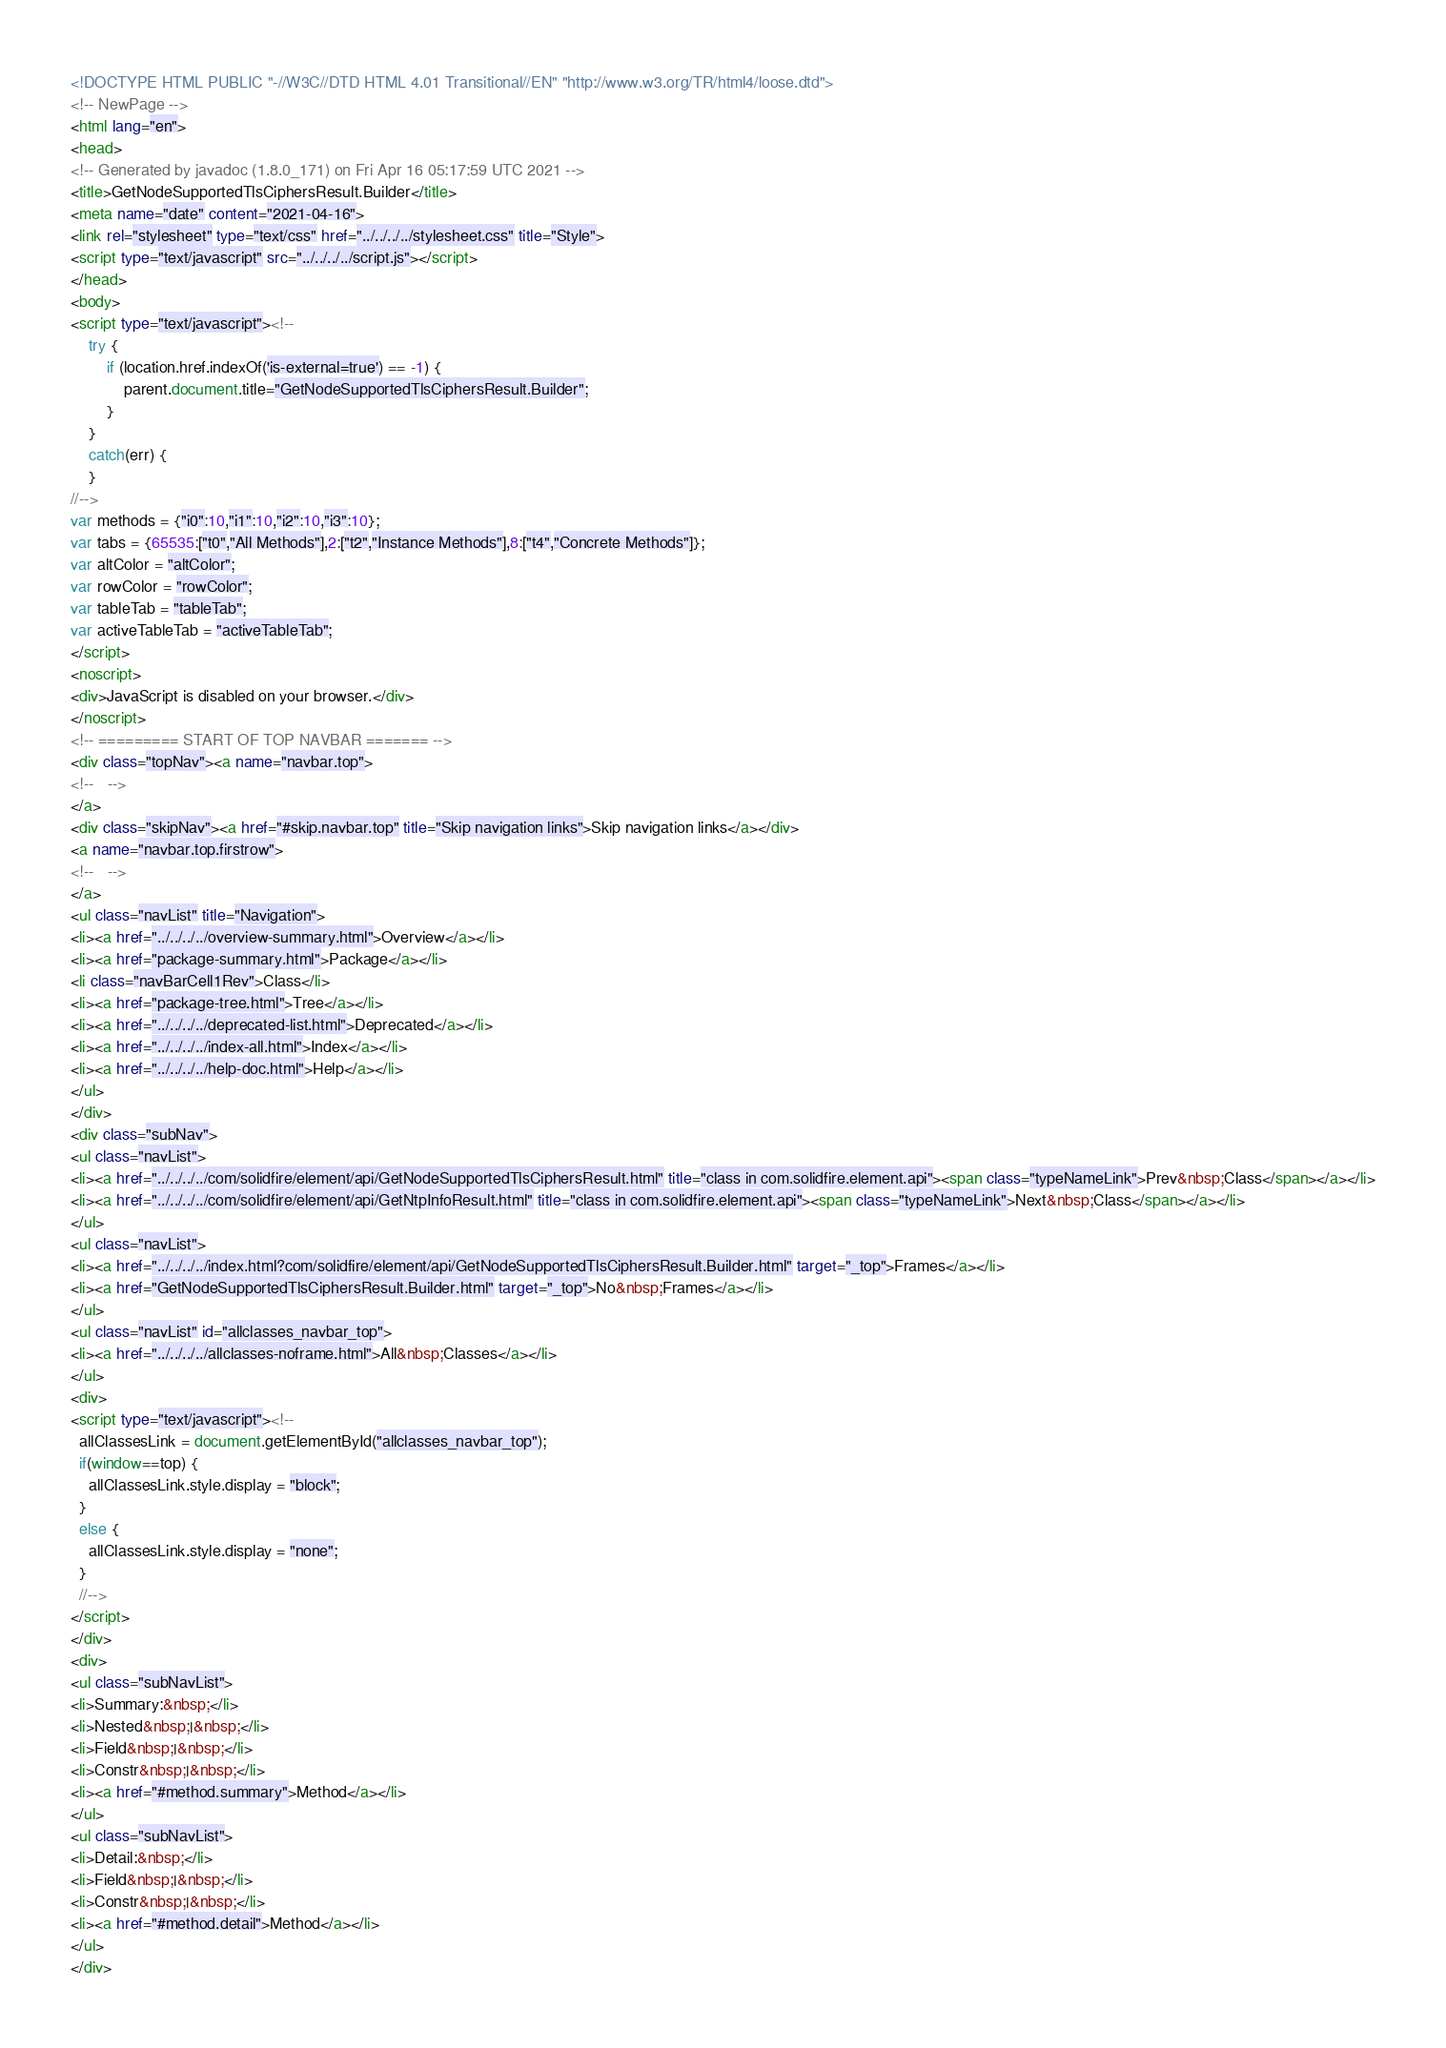Convert code to text. <code><loc_0><loc_0><loc_500><loc_500><_HTML_><!DOCTYPE HTML PUBLIC "-//W3C//DTD HTML 4.01 Transitional//EN" "http://www.w3.org/TR/html4/loose.dtd">
<!-- NewPage -->
<html lang="en">
<head>
<!-- Generated by javadoc (1.8.0_171) on Fri Apr 16 05:17:59 UTC 2021 -->
<title>GetNodeSupportedTlsCiphersResult.Builder</title>
<meta name="date" content="2021-04-16">
<link rel="stylesheet" type="text/css" href="../../../../stylesheet.css" title="Style">
<script type="text/javascript" src="../../../../script.js"></script>
</head>
<body>
<script type="text/javascript"><!--
    try {
        if (location.href.indexOf('is-external=true') == -1) {
            parent.document.title="GetNodeSupportedTlsCiphersResult.Builder";
        }
    }
    catch(err) {
    }
//-->
var methods = {"i0":10,"i1":10,"i2":10,"i3":10};
var tabs = {65535:["t0","All Methods"],2:["t2","Instance Methods"],8:["t4","Concrete Methods"]};
var altColor = "altColor";
var rowColor = "rowColor";
var tableTab = "tableTab";
var activeTableTab = "activeTableTab";
</script>
<noscript>
<div>JavaScript is disabled on your browser.</div>
</noscript>
<!-- ========= START OF TOP NAVBAR ======= -->
<div class="topNav"><a name="navbar.top">
<!--   -->
</a>
<div class="skipNav"><a href="#skip.navbar.top" title="Skip navigation links">Skip navigation links</a></div>
<a name="navbar.top.firstrow">
<!--   -->
</a>
<ul class="navList" title="Navigation">
<li><a href="../../../../overview-summary.html">Overview</a></li>
<li><a href="package-summary.html">Package</a></li>
<li class="navBarCell1Rev">Class</li>
<li><a href="package-tree.html">Tree</a></li>
<li><a href="../../../../deprecated-list.html">Deprecated</a></li>
<li><a href="../../../../index-all.html">Index</a></li>
<li><a href="../../../../help-doc.html">Help</a></li>
</ul>
</div>
<div class="subNav">
<ul class="navList">
<li><a href="../../../../com/solidfire/element/api/GetNodeSupportedTlsCiphersResult.html" title="class in com.solidfire.element.api"><span class="typeNameLink">Prev&nbsp;Class</span></a></li>
<li><a href="../../../../com/solidfire/element/api/GetNtpInfoResult.html" title="class in com.solidfire.element.api"><span class="typeNameLink">Next&nbsp;Class</span></a></li>
</ul>
<ul class="navList">
<li><a href="../../../../index.html?com/solidfire/element/api/GetNodeSupportedTlsCiphersResult.Builder.html" target="_top">Frames</a></li>
<li><a href="GetNodeSupportedTlsCiphersResult.Builder.html" target="_top">No&nbsp;Frames</a></li>
</ul>
<ul class="navList" id="allclasses_navbar_top">
<li><a href="../../../../allclasses-noframe.html">All&nbsp;Classes</a></li>
</ul>
<div>
<script type="text/javascript"><!--
  allClassesLink = document.getElementById("allclasses_navbar_top");
  if(window==top) {
    allClassesLink.style.display = "block";
  }
  else {
    allClassesLink.style.display = "none";
  }
  //-->
</script>
</div>
<div>
<ul class="subNavList">
<li>Summary:&nbsp;</li>
<li>Nested&nbsp;|&nbsp;</li>
<li>Field&nbsp;|&nbsp;</li>
<li>Constr&nbsp;|&nbsp;</li>
<li><a href="#method.summary">Method</a></li>
</ul>
<ul class="subNavList">
<li>Detail:&nbsp;</li>
<li>Field&nbsp;|&nbsp;</li>
<li>Constr&nbsp;|&nbsp;</li>
<li><a href="#method.detail">Method</a></li>
</ul>
</div></code> 